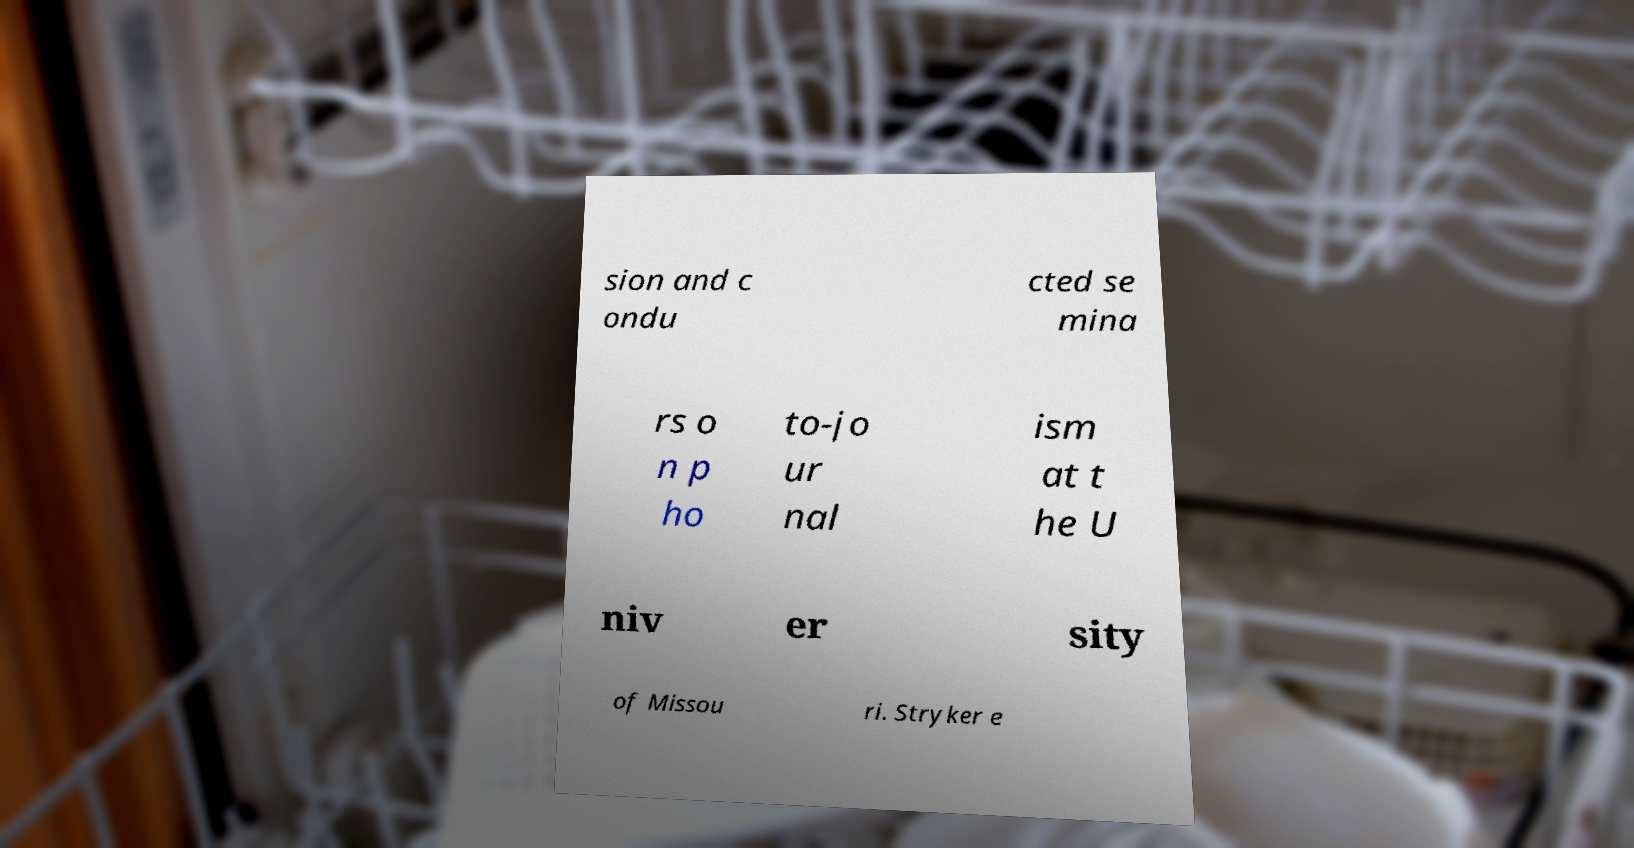Could you assist in decoding the text presented in this image and type it out clearly? sion and c ondu cted se mina rs o n p ho to-jo ur nal ism at t he U niv er sity of Missou ri. Stryker e 